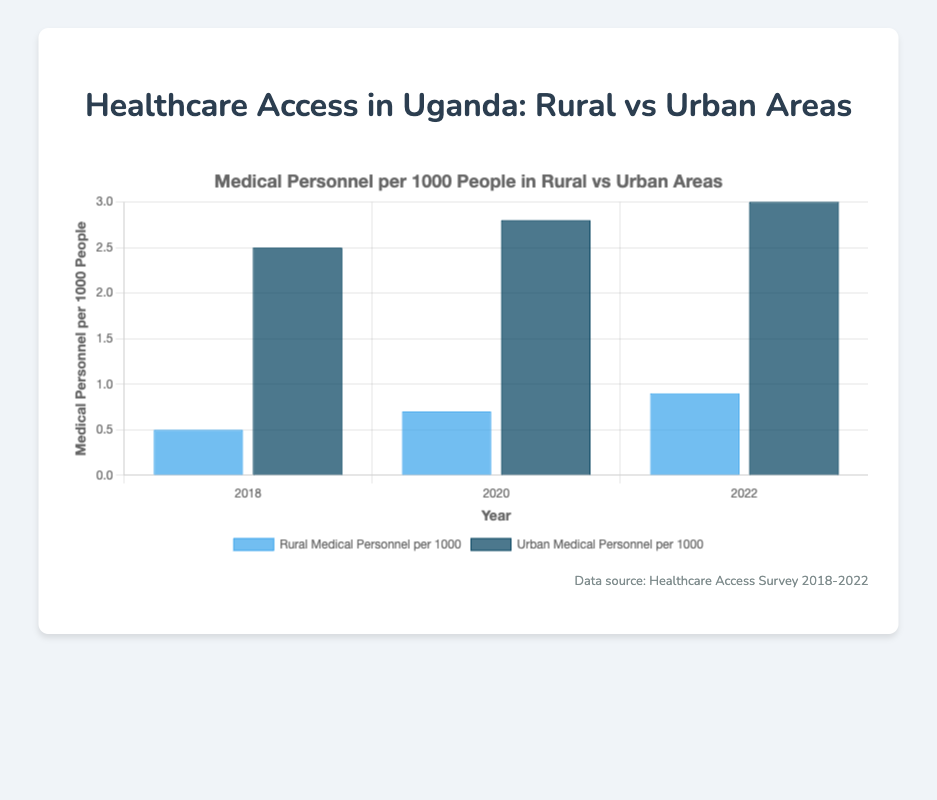Which area had more medical personnel per 1000 people in 2018? To find the area with more medical personnel per 1000 people in 2018, compare the values for Rural and Urban areas in that year. In 2018, the Rural area had 0.5, while the Urban area had 2.5 medical personnel per 1000 people. Therefore, Urban had more.
Answer: Urban By how much did the medical personnel per 1000 people in Rural areas increase from 2018 to 2022? To find the increase, subtract the value in 2018 from the value in 2022 for Rural areas. In 2018, it was 0.5, and in 2022, it was 0.9. The increase is 0.9 - 0.5 = 0.4.
Answer: 0.4 What is the average medical personnel per 1000 people across the Rural areas for the years provided? To find the average, sum the values for each year and divide by the number of years. The values are 0.5 (2018), 0.7 (2020), and 0.9 (2022), so the sum is 0.5 + 0.7 + 0.9 = 2.1. There are 3 years, so the average is 2.1 / 3 = 0.7.
Answer: 0.7 How did the trend of medical personnel per 1000 people change in Rural areas compared to Urban areas from 2018 to 2022? Look at the trend lines for both areas. In Rural areas, the values went from 0.5 (2018) to 0.7 (2020) to 0.9 (2022). In Urban areas, the values went from 2.5 (2018) to 2.8 (2020) to 3.0 (2022). Both areas show an increasing trend, but the Urban areas maintained a higher number throughout.
Answer: Both areas show an increasing trend Which colored bars represent Urban areas, and what were their values in 2020? Identify the color associated with Urban areas by noting the darker shade in the chart and check their values in 2020. The dark blue bars represent Urban areas. In 2020, the value for Urban areas was 2.8 medical personnel per 1000 people.
Answer: Dark blue, 2.8 What is the percent increase in medical personnel per 1000 people in Urban areas from 2018 to 2022? Calculate the percent increase using the formula: ((new value - old value) / old value) * 100. For Urban areas, the values are 2.5 (2018) and 3.0 (2022). The increase in medical personnel is (3.0 - 2.5) = 0.5. So, the percent increase is (0.5 / 2.5) * 100 = 20%.
Answer: 20% Between Rural and Urban areas, which had a more significant improvement in medical personnel per 1000 people over the years? Calculate the total increase for both areas from 2018 to 2022. For Rural: 0.9 - 0.5 = 0.4. For Urban: 3.0 - 2.5 = 0.5. Urban areas had a more significant improvement.
Answer: Urban What was the numerical difference in medical personnel per 1000 people between the areas with the lowest and highest values in 2022? Compare the 2022 values for both areas. For Rural, it was 0.9, and for Urban, it was 3.0. The difference is 3.0 - 0.9 = 2.1.
Answer: 2.1 